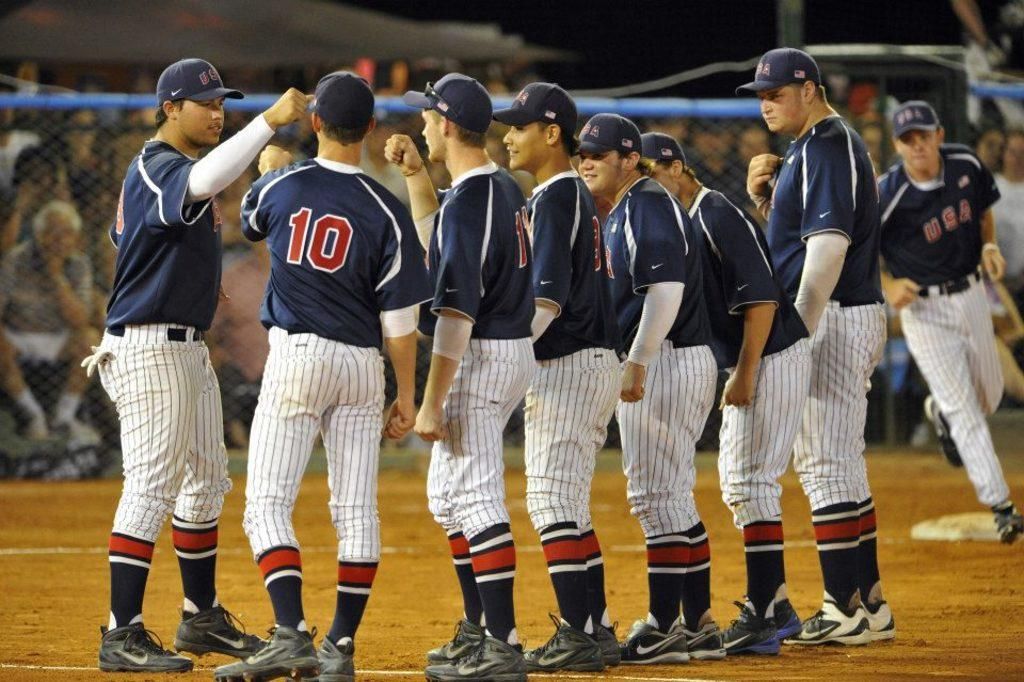<image>
Write a terse but informative summary of the picture. The baseball players on the field play for team USA. 